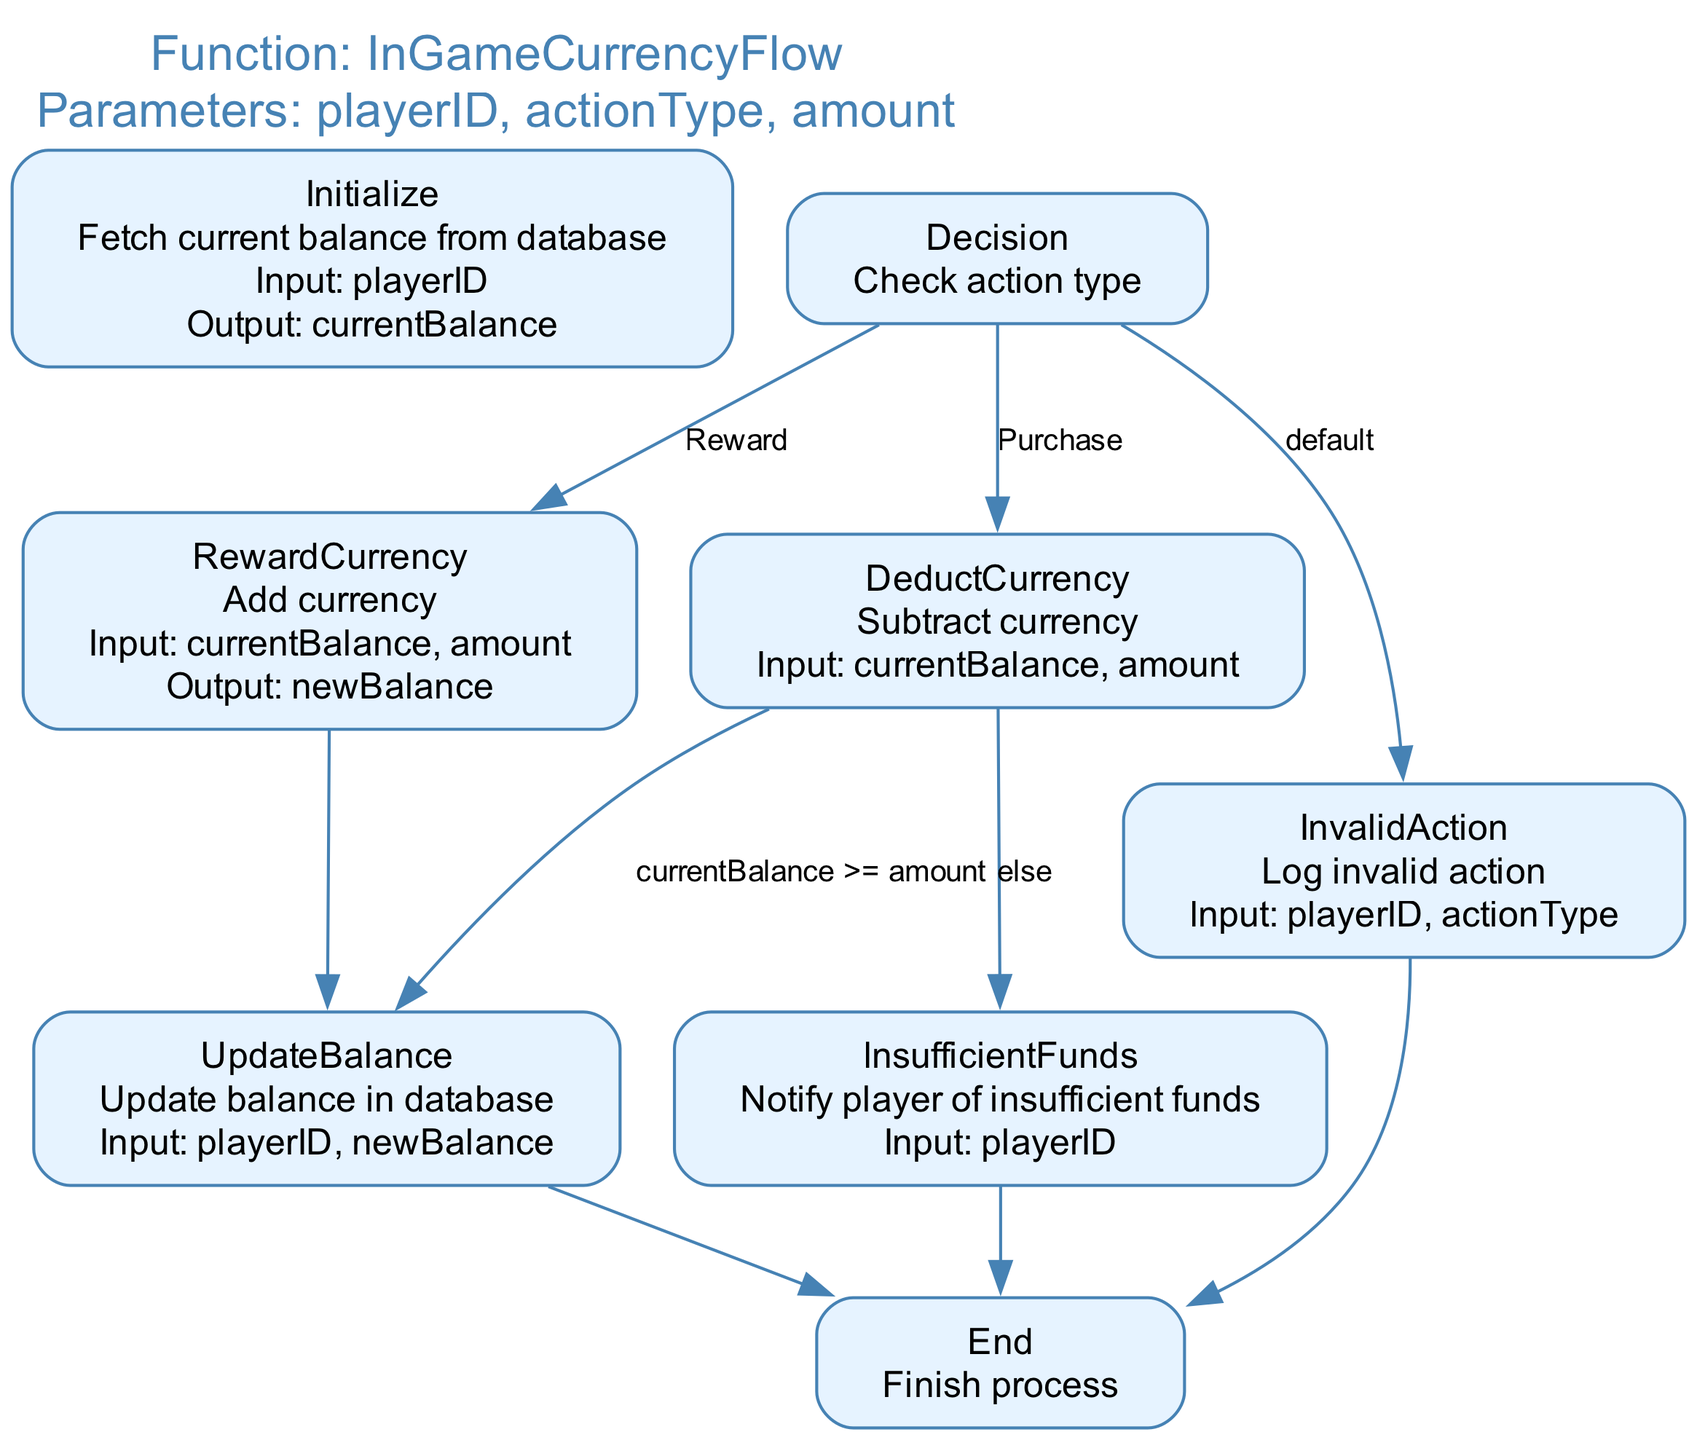What is the first action taken in the flowchart? The flowchart begins with the "Initialize" step, where it fetches the current balance from the database using the playerID.
Answer: Initialize How many steps are there in the flowchart? There are a total of eight steps detailed in the flowchart: Initialize, Decision, RewardCurrency, DeductCurrency, UpdateBalance, InvalidAction, InsufficientFunds, and End.
Answer: Eight What does the "Decision" step check? The "Decision" step checks the action type, which can lead to either "RewardCurrency" for rewarding currency, "DeductCurrency" for purchases, or "InvalidAction" for unrecognized actions.
Answer: Action type What will happen if the current balance is less than the amount during a purchase? If the current balance is less than the amount during a purchase, the flow will go to the "InsufficientFunds" step, where the player will be notified of insufficient funds.
Answer: InsufficientFunds What action occurs after successfully rewarding currency? After successfully rewarding currency, the flowchart proceeds to the "UpdateBalance" step, where the new balance is updated in the database.
Answer: UpdateBalance What output is generated after a successful purchase? Upon the successful deduction of currency for a purchase, the output generated is the new balance calculated as current balance minus the amount.
Answer: New balance What happens when an invalid action is detected? When an invalid action is detected, the flowchart goes to the "InvalidAction" step, which logs the invalid action and concludes with the "End" step.
Answer: End What is the final step in the flowchart? The final step in the flowchart is "End," which signifies the completion of the process without further actions.
Answer: End 